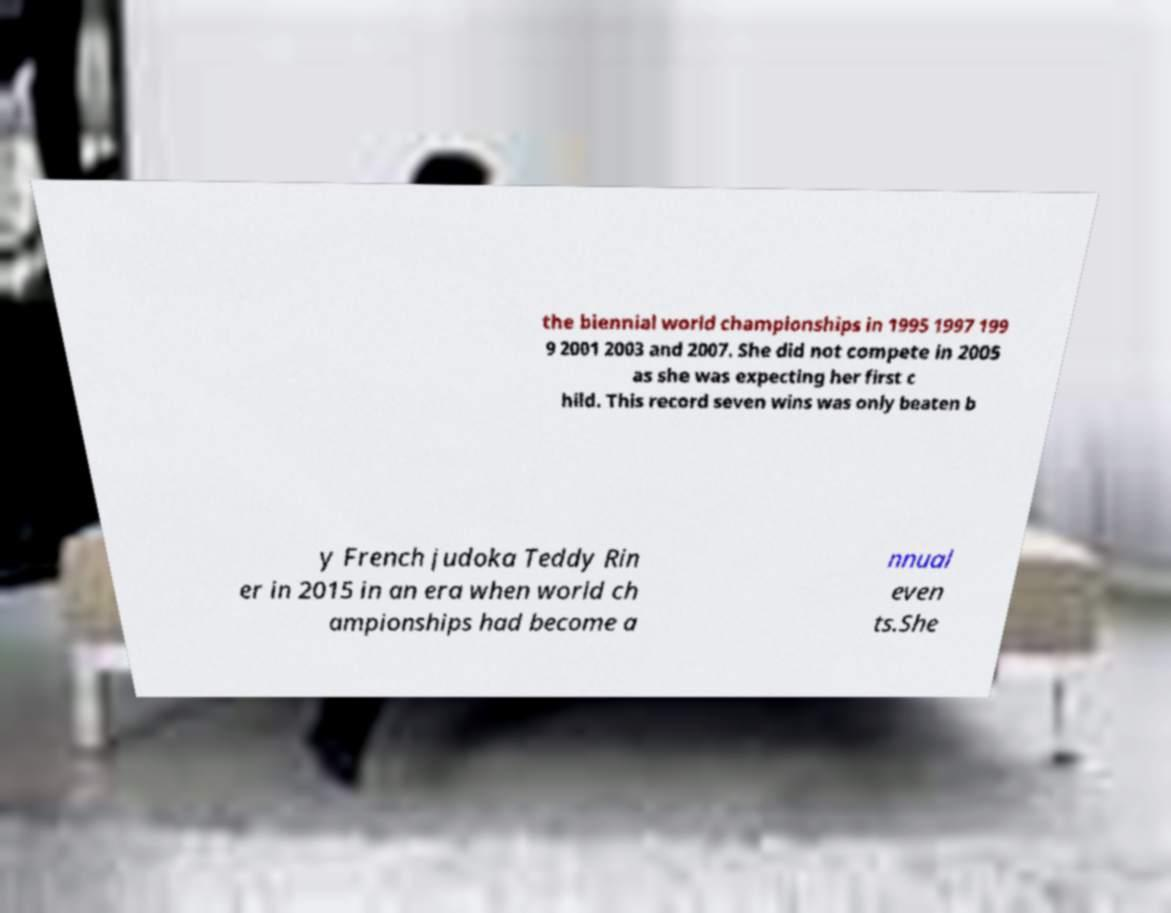Please read and relay the text visible in this image. What does it say? the biennial world championships in 1995 1997 199 9 2001 2003 and 2007. She did not compete in 2005 as she was expecting her first c hild. This record seven wins was only beaten b y French judoka Teddy Rin er in 2015 in an era when world ch ampionships had become a nnual even ts.She 